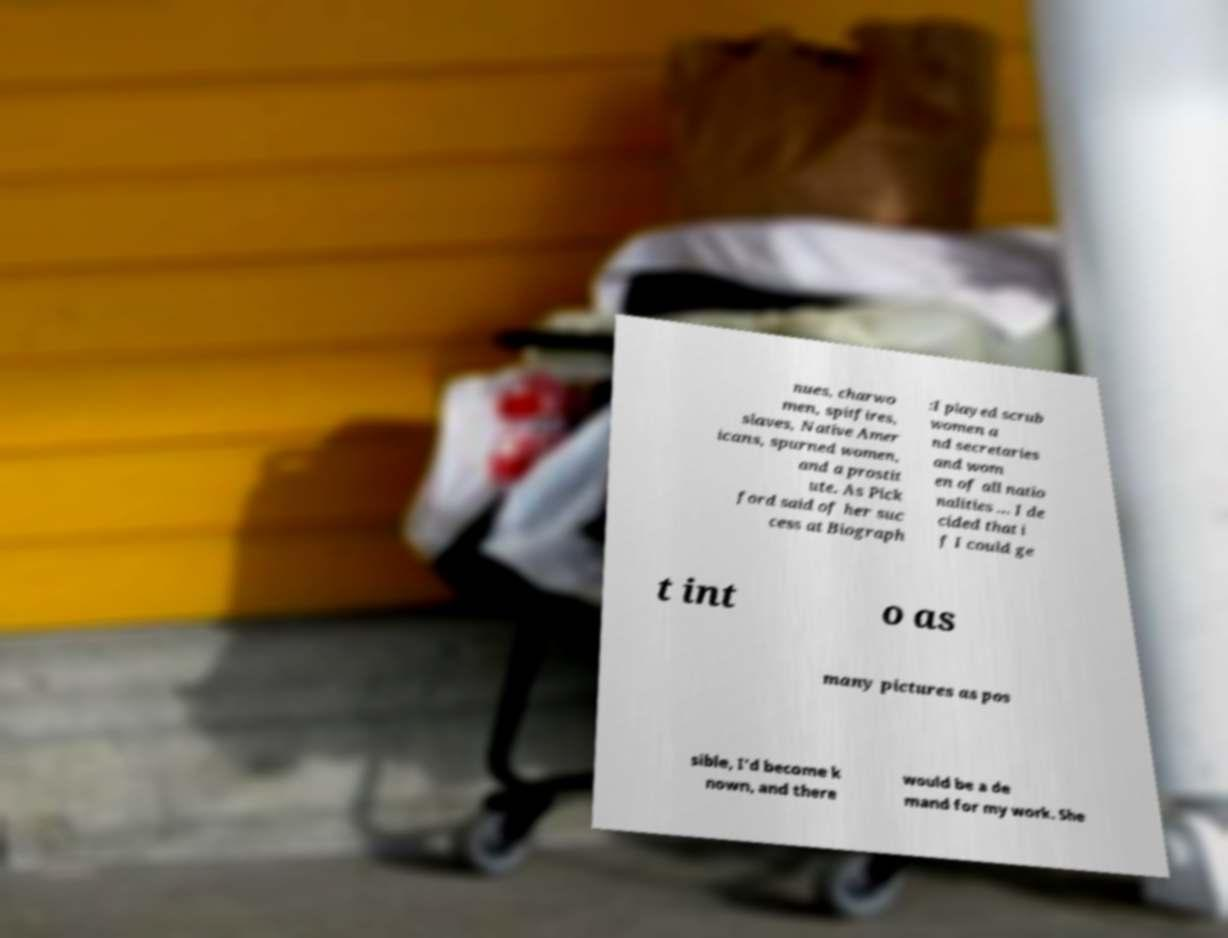Can you read and provide the text displayed in the image?This photo seems to have some interesting text. Can you extract and type it out for me? nues, charwo men, spitfires, slaves, Native Amer icans, spurned women, and a prostit ute. As Pick ford said of her suc cess at Biograph :I played scrub women a nd secretaries and wom en of all natio nalities ... I de cided that i f I could ge t int o as many pictures as pos sible, I'd become k nown, and there would be a de mand for my work. She 